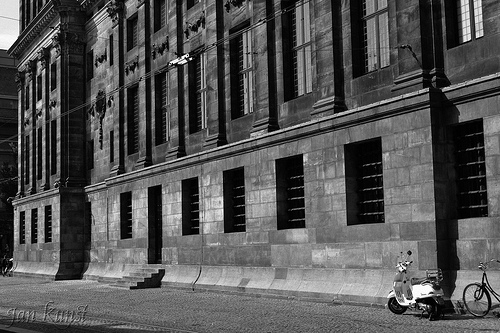What are the stairs in front of? The stairs are in front of the doorway. 